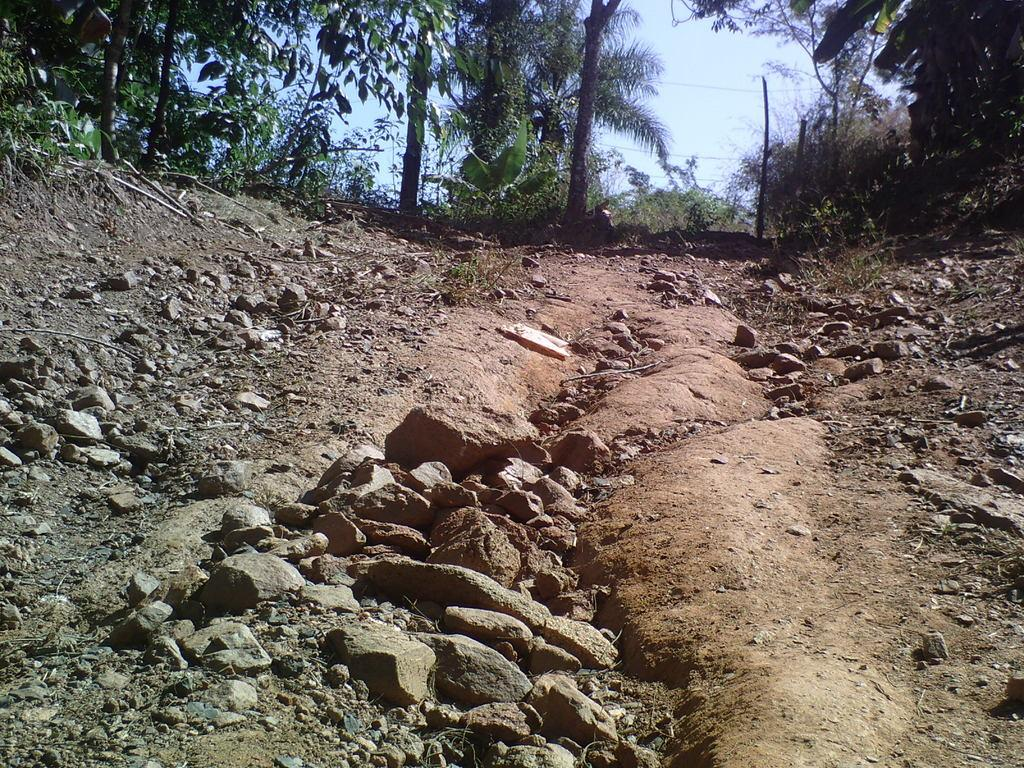What type of objects are in the foreground area of the image? There are stones in the foreground area of the image. What can be seen in the background of the image? There are trees in the background of the image. What is visible in the background of the image besides the trees? The sky is visible in the background of the image. Can you tell me where the curtain is located in the image? There is no curtain present in the image. What type of farm animals can be seen grazing in the image? There is no farm or farm animals present in the image. 